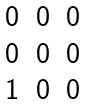<formula> <loc_0><loc_0><loc_500><loc_500>\begin{matrix} 0 & 0 & 0 \\ 0 & 0 & 0 \\ 1 & 0 & 0 \end{matrix}</formula> 